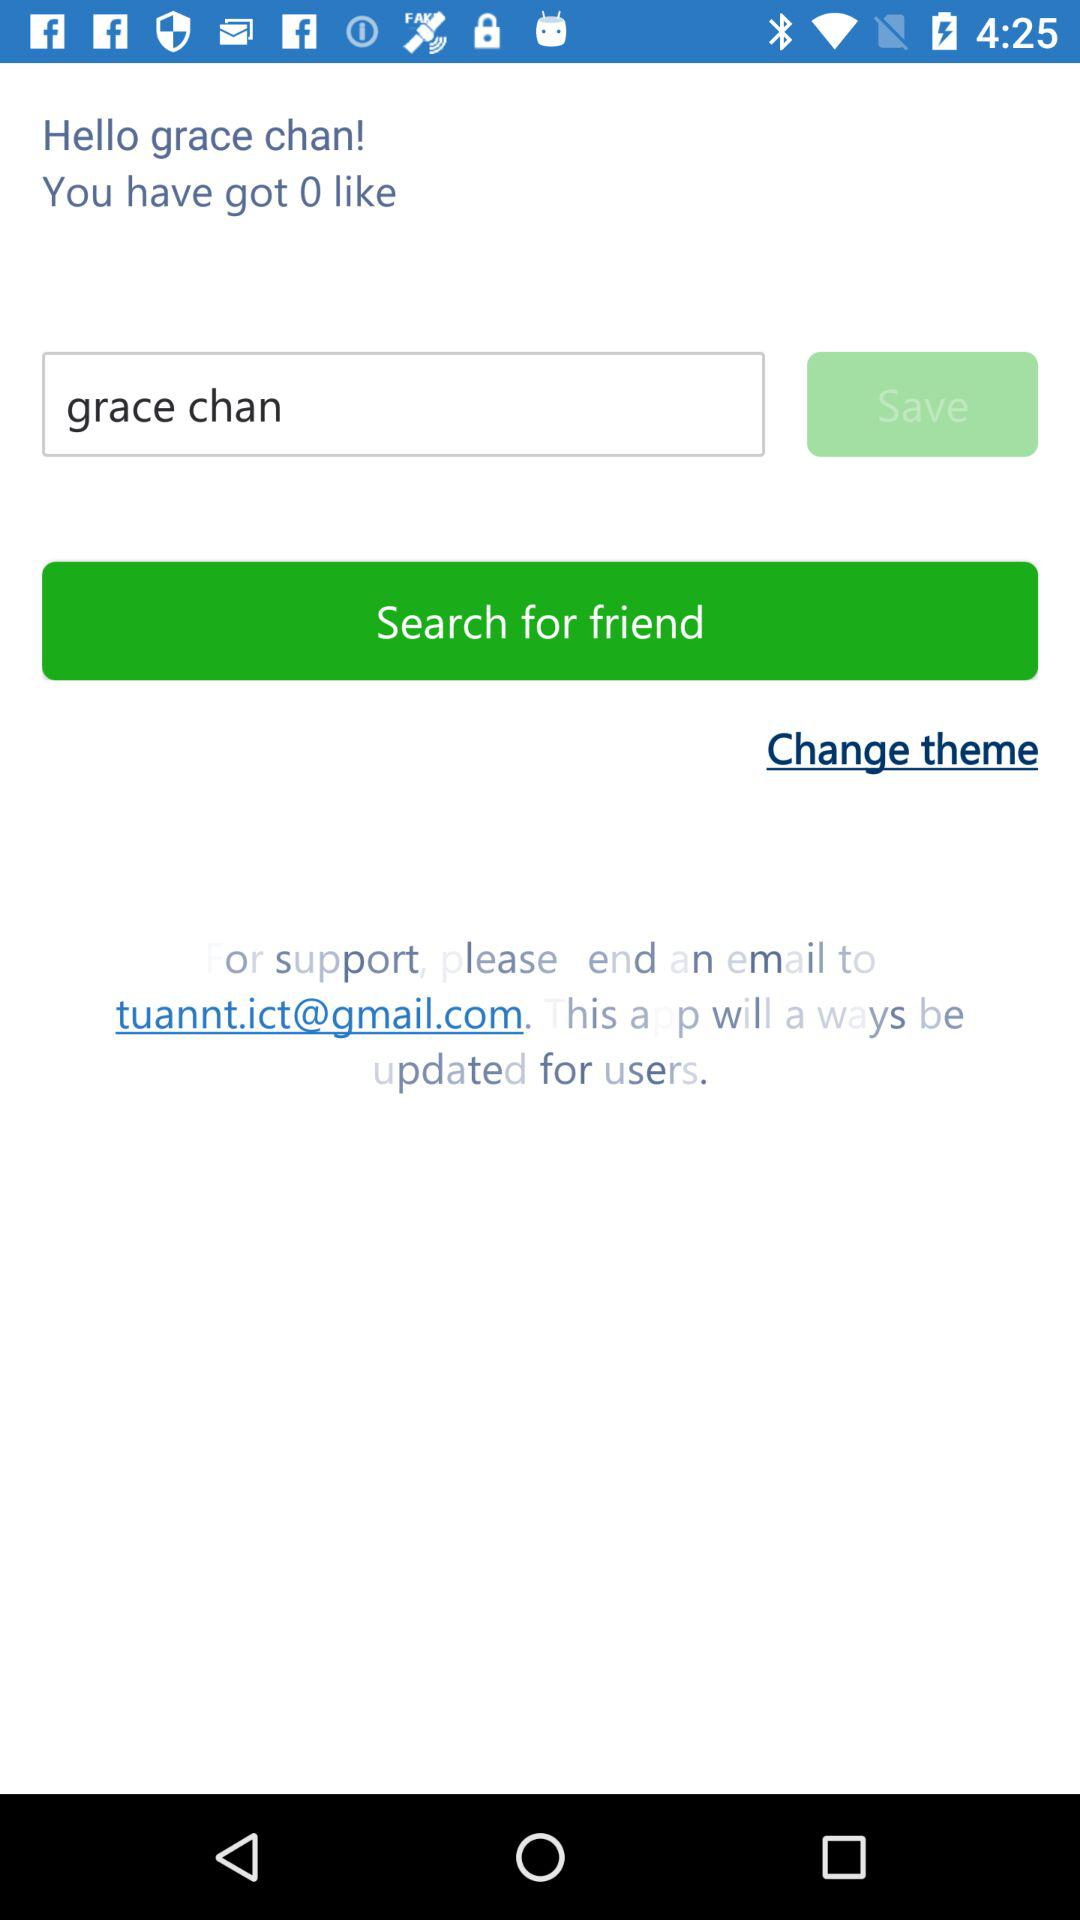What is the name of the user? The name of the user is Grace Chan. 